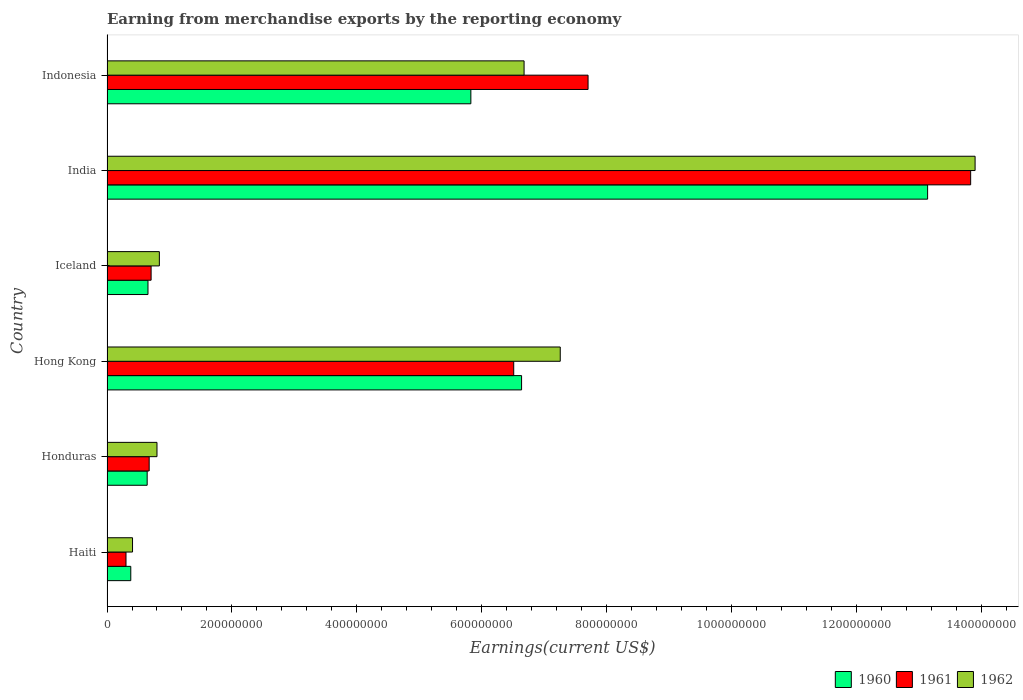How many different coloured bars are there?
Your response must be concise. 3. How many groups of bars are there?
Ensure brevity in your answer.  6. Are the number of bars per tick equal to the number of legend labels?
Offer a terse response. Yes. Are the number of bars on each tick of the Y-axis equal?
Give a very brief answer. Yes. How many bars are there on the 1st tick from the top?
Ensure brevity in your answer.  3. What is the label of the 1st group of bars from the top?
Give a very brief answer. Indonesia. In how many cases, is the number of bars for a given country not equal to the number of legend labels?
Your answer should be very brief. 0. What is the amount earned from merchandise exports in 1960 in Iceland?
Make the answer very short. 6.56e+07. Across all countries, what is the maximum amount earned from merchandise exports in 1961?
Provide a succinct answer. 1.38e+09. Across all countries, what is the minimum amount earned from merchandise exports in 1961?
Offer a terse response. 3.04e+07. In which country was the amount earned from merchandise exports in 1960 maximum?
Provide a succinct answer. India. In which country was the amount earned from merchandise exports in 1961 minimum?
Keep it short and to the point. Haiti. What is the total amount earned from merchandise exports in 1960 in the graph?
Provide a succinct answer. 2.73e+09. What is the difference between the amount earned from merchandise exports in 1960 in Honduras and that in Indonesia?
Offer a terse response. -5.18e+08. What is the difference between the amount earned from merchandise exports in 1962 in India and the amount earned from merchandise exports in 1961 in Haiti?
Your answer should be compact. 1.36e+09. What is the average amount earned from merchandise exports in 1962 per country?
Make the answer very short. 4.98e+08. What is the difference between the amount earned from merchandise exports in 1960 and amount earned from merchandise exports in 1961 in India?
Provide a short and direct response. -6.89e+07. What is the ratio of the amount earned from merchandise exports in 1961 in Haiti to that in Honduras?
Your answer should be very brief. 0.45. What is the difference between the highest and the second highest amount earned from merchandise exports in 1960?
Give a very brief answer. 6.50e+08. What is the difference between the highest and the lowest amount earned from merchandise exports in 1961?
Provide a succinct answer. 1.35e+09. In how many countries, is the amount earned from merchandise exports in 1961 greater than the average amount earned from merchandise exports in 1961 taken over all countries?
Keep it short and to the point. 3. What does the 3rd bar from the top in Honduras represents?
Provide a succinct answer. 1960. What does the 2nd bar from the bottom in Honduras represents?
Your answer should be very brief. 1961. Is it the case that in every country, the sum of the amount earned from merchandise exports in 1961 and amount earned from merchandise exports in 1962 is greater than the amount earned from merchandise exports in 1960?
Keep it short and to the point. Yes. How many countries are there in the graph?
Your response must be concise. 6. Does the graph contain any zero values?
Provide a succinct answer. No. Does the graph contain grids?
Make the answer very short. No. Where does the legend appear in the graph?
Provide a succinct answer. Bottom right. How many legend labels are there?
Ensure brevity in your answer.  3. How are the legend labels stacked?
Ensure brevity in your answer.  Horizontal. What is the title of the graph?
Keep it short and to the point. Earning from merchandise exports by the reporting economy. What is the label or title of the X-axis?
Your answer should be compact. Earnings(current US$). What is the Earnings(current US$) of 1960 in Haiti?
Offer a very short reply. 3.81e+07. What is the Earnings(current US$) of 1961 in Haiti?
Your answer should be compact. 3.04e+07. What is the Earnings(current US$) in 1962 in Haiti?
Make the answer very short. 4.09e+07. What is the Earnings(current US$) of 1960 in Honduras?
Give a very brief answer. 6.43e+07. What is the Earnings(current US$) of 1961 in Honduras?
Your answer should be compact. 6.75e+07. What is the Earnings(current US$) in 1962 in Honduras?
Keep it short and to the point. 8.00e+07. What is the Earnings(current US$) in 1960 in Hong Kong?
Your answer should be very brief. 6.64e+08. What is the Earnings(current US$) in 1961 in Hong Kong?
Provide a short and direct response. 6.51e+08. What is the Earnings(current US$) of 1962 in Hong Kong?
Ensure brevity in your answer.  7.26e+08. What is the Earnings(current US$) in 1960 in Iceland?
Provide a succinct answer. 6.56e+07. What is the Earnings(current US$) in 1961 in Iceland?
Give a very brief answer. 7.06e+07. What is the Earnings(current US$) in 1962 in Iceland?
Provide a succinct answer. 8.38e+07. What is the Earnings(current US$) in 1960 in India?
Your answer should be compact. 1.31e+09. What is the Earnings(current US$) in 1961 in India?
Give a very brief answer. 1.38e+09. What is the Earnings(current US$) of 1962 in India?
Your answer should be compact. 1.39e+09. What is the Earnings(current US$) of 1960 in Indonesia?
Keep it short and to the point. 5.82e+08. What is the Earnings(current US$) of 1961 in Indonesia?
Offer a very short reply. 7.70e+08. What is the Earnings(current US$) in 1962 in Indonesia?
Provide a succinct answer. 6.68e+08. Across all countries, what is the maximum Earnings(current US$) of 1960?
Your response must be concise. 1.31e+09. Across all countries, what is the maximum Earnings(current US$) in 1961?
Give a very brief answer. 1.38e+09. Across all countries, what is the maximum Earnings(current US$) of 1962?
Your response must be concise. 1.39e+09. Across all countries, what is the minimum Earnings(current US$) of 1960?
Provide a short and direct response. 3.81e+07. Across all countries, what is the minimum Earnings(current US$) of 1961?
Offer a very short reply. 3.04e+07. Across all countries, what is the minimum Earnings(current US$) of 1962?
Your answer should be very brief. 4.09e+07. What is the total Earnings(current US$) in 1960 in the graph?
Your answer should be very brief. 2.73e+09. What is the total Earnings(current US$) of 1961 in the graph?
Provide a succinct answer. 2.97e+09. What is the total Earnings(current US$) of 1962 in the graph?
Ensure brevity in your answer.  2.99e+09. What is the difference between the Earnings(current US$) in 1960 in Haiti and that in Honduras?
Your response must be concise. -2.62e+07. What is the difference between the Earnings(current US$) in 1961 in Haiti and that in Honduras?
Your answer should be very brief. -3.71e+07. What is the difference between the Earnings(current US$) of 1962 in Haiti and that in Honduras?
Your response must be concise. -3.91e+07. What is the difference between the Earnings(current US$) of 1960 in Haiti and that in Hong Kong?
Your answer should be very brief. -6.26e+08. What is the difference between the Earnings(current US$) of 1961 in Haiti and that in Hong Kong?
Provide a short and direct response. -6.21e+08. What is the difference between the Earnings(current US$) of 1962 in Haiti and that in Hong Kong?
Offer a terse response. -6.85e+08. What is the difference between the Earnings(current US$) of 1960 in Haiti and that in Iceland?
Make the answer very short. -2.75e+07. What is the difference between the Earnings(current US$) in 1961 in Haiti and that in Iceland?
Your answer should be very brief. -4.02e+07. What is the difference between the Earnings(current US$) in 1962 in Haiti and that in Iceland?
Provide a short and direct response. -4.29e+07. What is the difference between the Earnings(current US$) of 1960 in Haiti and that in India?
Keep it short and to the point. -1.28e+09. What is the difference between the Earnings(current US$) of 1961 in Haiti and that in India?
Your response must be concise. -1.35e+09. What is the difference between the Earnings(current US$) in 1962 in Haiti and that in India?
Give a very brief answer. -1.35e+09. What is the difference between the Earnings(current US$) of 1960 in Haiti and that in Indonesia?
Make the answer very short. -5.44e+08. What is the difference between the Earnings(current US$) in 1961 in Haiti and that in Indonesia?
Provide a succinct answer. -7.40e+08. What is the difference between the Earnings(current US$) of 1962 in Haiti and that in Indonesia?
Ensure brevity in your answer.  -6.27e+08. What is the difference between the Earnings(current US$) in 1960 in Honduras and that in Hong Kong?
Provide a succinct answer. -5.99e+08. What is the difference between the Earnings(current US$) of 1961 in Honduras and that in Hong Kong?
Your answer should be very brief. -5.84e+08. What is the difference between the Earnings(current US$) in 1962 in Honduras and that in Hong Kong?
Offer a terse response. -6.46e+08. What is the difference between the Earnings(current US$) in 1960 in Honduras and that in Iceland?
Provide a succinct answer. -1.30e+06. What is the difference between the Earnings(current US$) of 1961 in Honduras and that in Iceland?
Ensure brevity in your answer.  -3.10e+06. What is the difference between the Earnings(current US$) in 1962 in Honduras and that in Iceland?
Your response must be concise. -3.80e+06. What is the difference between the Earnings(current US$) of 1960 in Honduras and that in India?
Offer a very short reply. -1.25e+09. What is the difference between the Earnings(current US$) of 1961 in Honduras and that in India?
Make the answer very short. -1.31e+09. What is the difference between the Earnings(current US$) in 1962 in Honduras and that in India?
Offer a terse response. -1.31e+09. What is the difference between the Earnings(current US$) of 1960 in Honduras and that in Indonesia?
Provide a succinct answer. -5.18e+08. What is the difference between the Earnings(current US$) of 1961 in Honduras and that in Indonesia?
Make the answer very short. -7.02e+08. What is the difference between the Earnings(current US$) in 1962 in Honduras and that in Indonesia?
Give a very brief answer. -5.88e+08. What is the difference between the Earnings(current US$) of 1960 in Hong Kong and that in Iceland?
Provide a short and direct response. 5.98e+08. What is the difference between the Earnings(current US$) of 1961 in Hong Kong and that in Iceland?
Provide a succinct answer. 5.80e+08. What is the difference between the Earnings(current US$) of 1962 in Hong Kong and that in Iceland?
Make the answer very short. 6.42e+08. What is the difference between the Earnings(current US$) in 1960 in Hong Kong and that in India?
Your answer should be compact. -6.50e+08. What is the difference between the Earnings(current US$) in 1961 in Hong Kong and that in India?
Your answer should be compact. -7.31e+08. What is the difference between the Earnings(current US$) in 1962 in Hong Kong and that in India?
Give a very brief answer. -6.64e+08. What is the difference between the Earnings(current US$) in 1960 in Hong Kong and that in Indonesia?
Your answer should be very brief. 8.12e+07. What is the difference between the Earnings(current US$) of 1961 in Hong Kong and that in Indonesia?
Give a very brief answer. -1.19e+08. What is the difference between the Earnings(current US$) in 1962 in Hong Kong and that in Indonesia?
Give a very brief answer. 5.79e+07. What is the difference between the Earnings(current US$) of 1960 in Iceland and that in India?
Your answer should be compact. -1.25e+09. What is the difference between the Earnings(current US$) of 1961 in Iceland and that in India?
Provide a succinct answer. -1.31e+09. What is the difference between the Earnings(current US$) in 1962 in Iceland and that in India?
Provide a short and direct response. -1.31e+09. What is the difference between the Earnings(current US$) of 1960 in Iceland and that in Indonesia?
Your answer should be compact. -5.17e+08. What is the difference between the Earnings(current US$) of 1961 in Iceland and that in Indonesia?
Provide a short and direct response. -6.99e+08. What is the difference between the Earnings(current US$) in 1962 in Iceland and that in Indonesia?
Provide a succinct answer. -5.84e+08. What is the difference between the Earnings(current US$) in 1960 in India and that in Indonesia?
Ensure brevity in your answer.  7.31e+08. What is the difference between the Earnings(current US$) in 1961 in India and that in Indonesia?
Your answer should be very brief. 6.12e+08. What is the difference between the Earnings(current US$) of 1962 in India and that in Indonesia?
Your answer should be very brief. 7.22e+08. What is the difference between the Earnings(current US$) in 1960 in Haiti and the Earnings(current US$) in 1961 in Honduras?
Offer a terse response. -2.94e+07. What is the difference between the Earnings(current US$) in 1960 in Haiti and the Earnings(current US$) in 1962 in Honduras?
Make the answer very short. -4.19e+07. What is the difference between the Earnings(current US$) of 1961 in Haiti and the Earnings(current US$) of 1962 in Honduras?
Provide a short and direct response. -4.96e+07. What is the difference between the Earnings(current US$) in 1960 in Haiti and the Earnings(current US$) in 1961 in Hong Kong?
Your answer should be very brief. -6.13e+08. What is the difference between the Earnings(current US$) of 1960 in Haiti and the Earnings(current US$) of 1962 in Hong Kong?
Keep it short and to the point. -6.87e+08. What is the difference between the Earnings(current US$) in 1961 in Haiti and the Earnings(current US$) in 1962 in Hong Kong?
Your answer should be compact. -6.95e+08. What is the difference between the Earnings(current US$) in 1960 in Haiti and the Earnings(current US$) in 1961 in Iceland?
Make the answer very short. -3.25e+07. What is the difference between the Earnings(current US$) of 1960 in Haiti and the Earnings(current US$) of 1962 in Iceland?
Your answer should be very brief. -4.57e+07. What is the difference between the Earnings(current US$) of 1961 in Haiti and the Earnings(current US$) of 1962 in Iceland?
Keep it short and to the point. -5.34e+07. What is the difference between the Earnings(current US$) in 1960 in Haiti and the Earnings(current US$) in 1961 in India?
Make the answer very short. -1.34e+09. What is the difference between the Earnings(current US$) in 1960 in Haiti and the Earnings(current US$) in 1962 in India?
Provide a succinct answer. -1.35e+09. What is the difference between the Earnings(current US$) of 1961 in Haiti and the Earnings(current US$) of 1962 in India?
Offer a very short reply. -1.36e+09. What is the difference between the Earnings(current US$) of 1960 in Haiti and the Earnings(current US$) of 1961 in Indonesia?
Keep it short and to the point. -7.32e+08. What is the difference between the Earnings(current US$) of 1960 in Haiti and the Earnings(current US$) of 1962 in Indonesia?
Your answer should be compact. -6.30e+08. What is the difference between the Earnings(current US$) of 1961 in Haiti and the Earnings(current US$) of 1962 in Indonesia?
Provide a succinct answer. -6.37e+08. What is the difference between the Earnings(current US$) in 1960 in Honduras and the Earnings(current US$) in 1961 in Hong Kong?
Your response must be concise. -5.87e+08. What is the difference between the Earnings(current US$) of 1960 in Honduras and the Earnings(current US$) of 1962 in Hong Kong?
Provide a short and direct response. -6.61e+08. What is the difference between the Earnings(current US$) of 1961 in Honduras and the Earnings(current US$) of 1962 in Hong Kong?
Offer a very short reply. -6.58e+08. What is the difference between the Earnings(current US$) of 1960 in Honduras and the Earnings(current US$) of 1961 in Iceland?
Offer a very short reply. -6.30e+06. What is the difference between the Earnings(current US$) in 1960 in Honduras and the Earnings(current US$) in 1962 in Iceland?
Provide a short and direct response. -1.95e+07. What is the difference between the Earnings(current US$) of 1961 in Honduras and the Earnings(current US$) of 1962 in Iceland?
Ensure brevity in your answer.  -1.63e+07. What is the difference between the Earnings(current US$) of 1960 in Honduras and the Earnings(current US$) of 1961 in India?
Your answer should be compact. -1.32e+09. What is the difference between the Earnings(current US$) in 1960 in Honduras and the Earnings(current US$) in 1962 in India?
Your answer should be very brief. -1.33e+09. What is the difference between the Earnings(current US$) in 1961 in Honduras and the Earnings(current US$) in 1962 in India?
Your answer should be compact. -1.32e+09. What is the difference between the Earnings(current US$) of 1960 in Honduras and the Earnings(current US$) of 1961 in Indonesia?
Provide a short and direct response. -7.06e+08. What is the difference between the Earnings(current US$) in 1960 in Honduras and the Earnings(current US$) in 1962 in Indonesia?
Ensure brevity in your answer.  -6.03e+08. What is the difference between the Earnings(current US$) in 1961 in Honduras and the Earnings(current US$) in 1962 in Indonesia?
Give a very brief answer. -6.00e+08. What is the difference between the Earnings(current US$) of 1960 in Hong Kong and the Earnings(current US$) of 1961 in Iceland?
Ensure brevity in your answer.  5.93e+08. What is the difference between the Earnings(current US$) in 1960 in Hong Kong and the Earnings(current US$) in 1962 in Iceland?
Your answer should be compact. 5.80e+08. What is the difference between the Earnings(current US$) of 1961 in Hong Kong and the Earnings(current US$) of 1962 in Iceland?
Keep it short and to the point. 5.67e+08. What is the difference between the Earnings(current US$) in 1960 in Hong Kong and the Earnings(current US$) in 1961 in India?
Offer a very short reply. -7.19e+08. What is the difference between the Earnings(current US$) of 1960 in Hong Kong and the Earnings(current US$) of 1962 in India?
Give a very brief answer. -7.26e+08. What is the difference between the Earnings(current US$) of 1961 in Hong Kong and the Earnings(current US$) of 1962 in India?
Offer a terse response. -7.38e+08. What is the difference between the Earnings(current US$) of 1960 in Hong Kong and the Earnings(current US$) of 1961 in Indonesia?
Give a very brief answer. -1.06e+08. What is the difference between the Earnings(current US$) in 1961 in Hong Kong and the Earnings(current US$) in 1962 in Indonesia?
Ensure brevity in your answer.  -1.66e+07. What is the difference between the Earnings(current US$) of 1960 in Iceland and the Earnings(current US$) of 1961 in India?
Your response must be concise. -1.32e+09. What is the difference between the Earnings(current US$) of 1960 in Iceland and the Earnings(current US$) of 1962 in India?
Provide a succinct answer. -1.32e+09. What is the difference between the Earnings(current US$) in 1961 in Iceland and the Earnings(current US$) in 1962 in India?
Ensure brevity in your answer.  -1.32e+09. What is the difference between the Earnings(current US$) in 1960 in Iceland and the Earnings(current US$) in 1961 in Indonesia?
Provide a succinct answer. -7.04e+08. What is the difference between the Earnings(current US$) of 1960 in Iceland and the Earnings(current US$) of 1962 in Indonesia?
Your answer should be very brief. -6.02e+08. What is the difference between the Earnings(current US$) in 1961 in Iceland and the Earnings(current US$) in 1962 in Indonesia?
Your answer should be very brief. -5.97e+08. What is the difference between the Earnings(current US$) in 1960 in India and the Earnings(current US$) in 1961 in Indonesia?
Your answer should be compact. 5.44e+08. What is the difference between the Earnings(current US$) in 1960 in India and the Earnings(current US$) in 1962 in Indonesia?
Your answer should be compact. 6.46e+08. What is the difference between the Earnings(current US$) of 1961 in India and the Earnings(current US$) of 1962 in Indonesia?
Make the answer very short. 7.15e+08. What is the average Earnings(current US$) in 1960 per country?
Keep it short and to the point. 4.55e+08. What is the average Earnings(current US$) of 1961 per country?
Your answer should be compact. 4.95e+08. What is the average Earnings(current US$) in 1962 per country?
Give a very brief answer. 4.98e+08. What is the difference between the Earnings(current US$) of 1960 and Earnings(current US$) of 1961 in Haiti?
Offer a very short reply. 7.64e+06. What is the difference between the Earnings(current US$) of 1960 and Earnings(current US$) of 1962 in Haiti?
Your answer should be compact. -2.82e+06. What is the difference between the Earnings(current US$) of 1961 and Earnings(current US$) of 1962 in Haiti?
Offer a very short reply. -1.05e+07. What is the difference between the Earnings(current US$) in 1960 and Earnings(current US$) in 1961 in Honduras?
Keep it short and to the point. -3.20e+06. What is the difference between the Earnings(current US$) of 1960 and Earnings(current US$) of 1962 in Honduras?
Your answer should be very brief. -1.57e+07. What is the difference between the Earnings(current US$) in 1961 and Earnings(current US$) in 1962 in Honduras?
Your answer should be compact. -1.25e+07. What is the difference between the Earnings(current US$) of 1960 and Earnings(current US$) of 1961 in Hong Kong?
Give a very brief answer. 1.26e+07. What is the difference between the Earnings(current US$) in 1960 and Earnings(current US$) in 1962 in Hong Kong?
Your response must be concise. -6.19e+07. What is the difference between the Earnings(current US$) of 1961 and Earnings(current US$) of 1962 in Hong Kong?
Keep it short and to the point. -7.45e+07. What is the difference between the Earnings(current US$) in 1960 and Earnings(current US$) in 1961 in Iceland?
Keep it short and to the point. -5.00e+06. What is the difference between the Earnings(current US$) of 1960 and Earnings(current US$) of 1962 in Iceland?
Your answer should be very brief. -1.82e+07. What is the difference between the Earnings(current US$) in 1961 and Earnings(current US$) in 1962 in Iceland?
Give a very brief answer. -1.32e+07. What is the difference between the Earnings(current US$) of 1960 and Earnings(current US$) of 1961 in India?
Provide a succinct answer. -6.89e+07. What is the difference between the Earnings(current US$) of 1960 and Earnings(current US$) of 1962 in India?
Keep it short and to the point. -7.60e+07. What is the difference between the Earnings(current US$) of 1961 and Earnings(current US$) of 1962 in India?
Provide a succinct answer. -7.10e+06. What is the difference between the Earnings(current US$) in 1960 and Earnings(current US$) in 1961 in Indonesia?
Offer a very short reply. -1.88e+08. What is the difference between the Earnings(current US$) of 1960 and Earnings(current US$) of 1962 in Indonesia?
Offer a very short reply. -8.52e+07. What is the difference between the Earnings(current US$) of 1961 and Earnings(current US$) of 1962 in Indonesia?
Your answer should be very brief. 1.02e+08. What is the ratio of the Earnings(current US$) of 1960 in Haiti to that in Honduras?
Keep it short and to the point. 0.59. What is the ratio of the Earnings(current US$) of 1961 in Haiti to that in Honduras?
Keep it short and to the point. 0.45. What is the ratio of the Earnings(current US$) in 1962 in Haiti to that in Honduras?
Your answer should be very brief. 0.51. What is the ratio of the Earnings(current US$) of 1960 in Haiti to that in Hong Kong?
Offer a very short reply. 0.06. What is the ratio of the Earnings(current US$) of 1961 in Haiti to that in Hong Kong?
Keep it short and to the point. 0.05. What is the ratio of the Earnings(current US$) of 1962 in Haiti to that in Hong Kong?
Offer a terse response. 0.06. What is the ratio of the Earnings(current US$) of 1960 in Haiti to that in Iceland?
Offer a terse response. 0.58. What is the ratio of the Earnings(current US$) of 1961 in Haiti to that in Iceland?
Your answer should be compact. 0.43. What is the ratio of the Earnings(current US$) of 1962 in Haiti to that in Iceland?
Your response must be concise. 0.49. What is the ratio of the Earnings(current US$) of 1960 in Haiti to that in India?
Your response must be concise. 0.03. What is the ratio of the Earnings(current US$) in 1961 in Haiti to that in India?
Offer a very short reply. 0.02. What is the ratio of the Earnings(current US$) of 1962 in Haiti to that in India?
Your answer should be very brief. 0.03. What is the ratio of the Earnings(current US$) in 1960 in Haiti to that in Indonesia?
Your answer should be compact. 0.07. What is the ratio of the Earnings(current US$) in 1961 in Haiti to that in Indonesia?
Offer a terse response. 0.04. What is the ratio of the Earnings(current US$) of 1962 in Haiti to that in Indonesia?
Provide a succinct answer. 0.06. What is the ratio of the Earnings(current US$) in 1960 in Honduras to that in Hong Kong?
Give a very brief answer. 0.1. What is the ratio of the Earnings(current US$) of 1961 in Honduras to that in Hong Kong?
Offer a terse response. 0.1. What is the ratio of the Earnings(current US$) of 1962 in Honduras to that in Hong Kong?
Provide a succinct answer. 0.11. What is the ratio of the Earnings(current US$) in 1960 in Honduras to that in Iceland?
Your answer should be compact. 0.98. What is the ratio of the Earnings(current US$) of 1961 in Honduras to that in Iceland?
Offer a very short reply. 0.96. What is the ratio of the Earnings(current US$) of 1962 in Honduras to that in Iceland?
Make the answer very short. 0.95. What is the ratio of the Earnings(current US$) in 1960 in Honduras to that in India?
Make the answer very short. 0.05. What is the ratio of the Earnings(current US$) of 1961 in Honduras to that in India?
Offer a very short reply. 0.05. What is the ratio of the Earnings(current US$) of 1962 in Honduras to that in India?
Your answer should be compact. 0.06. What is the ratio of the Earnings(current US$) of 1960 in Honduras to that in Indonesia?
Your response must be concise. 0.11. What is the ratio of the Earnings(current US$) in 1961 in Honduras to that in Indonesia?
Ensure brevity in your answer.  0.09. What is the ratio of the Earnings(current US$) of 1962 in Honduras to that in Indonesia?
Your response must be concise. 0.12. What is the ratio of the Earnings(current US$) of 1960 in Hong Kong to that in Iceland?
Ensure brevity in your answer.  10.12. What is the ratio of the Earnings(current US$) of 1961 in Hong Kong to that in Iceland?
Provide a succinct answer. 9.22. What is the ratio of the Earnings(current US$) of 1962 in Hong Kong to that in Iceland?
Offer a terse response. 8.66. What is the ratio of the Earnings(current US$) in 1960 in Hong Kong to that in India?
Your answer should be very brief. 0.51. What is the ratio of the Earnings(current US$) in 1961 in Hong Kong to that in India?
Give a very brief answer. 0.47. What is the ratio of the Earnings(current US$) in 1962 in Hong Kong to that in India?
Keep it short and to the point. 0.52. What is the ratio of the Earnings(current US$) in 1960 in Hong Kong to that in Indonesia?
Your response must be concise. 1.14. What is the ratio of the Earnings(current US$) in 1961 in Hong Kong to that in Indonesia?
Your response must be concise. 0.85. What is the ratio of the Earnings(current US$) of 1962 in Hong Kong to that in Indonesia?
Offer a terse response. 1.09. What is the ratio of the Earnings(current US$) of 1960 in Iceland to that in India?
Your answer should be compact. 0.05. What is the ratio of the Earnings(current US$) of 1961 in Iceland to that in India?
Keep it short and to the point. 0.05. What is the ratio of the Earnings(current US$) in 1962 in Iceland to that in India?
Offer a very short reply. 0.06. What is the ratio of the Earnings(current US$) in 1960 in Iceland to that in Indonesia?
Your answer should be compact. 0.11. What is the ratio of the Earnings(current US$) in 1961 in Iceland to that in Indonesia?
Provide a short and direct response. 0.09. What is the ratio of the Earnings(current US$) in 1962 in Iceland to that in Indonesia?
Offer a very short reply. 0.13. What is the ratio of the Earnings(current US$) in 1960 in India to that in Indonesia?
Offer a terse response. 2.26. What is the ratio of the Earnings(current US$) in 1961 in India to that in Indonesia?
Ensure brevity in your answer.  1.8. What is the ratio of the Earnings(current US$) of 1962 in India to that in Indonesia?
Offer a very short reply. 2.08. What is the difference between the highest and the second highest Earnings(current US$) in 1960?
Ensure brevity in your answer.  6.50e+08. What is the difference between the highest and the second highest Earnings(current US$) in 1961?
Give a very brief answer. 6.12e+08. What is the difference between the highest and the second highest Earnings(current US$) in 1962?
Keep it short and to the point. 6.64e+08. What is the difference between the highest and the lowest Earnings(current US$) of 1960?
Your answer should be compact. 1.28e+09. What is the difference between the highest and the lowest Earnings(current US$) in 1961?
Provide a succinct answer. 1.35e+09. What is the difference between the highest and the lowest Earnings(current US$) in 1962?
Your response must be concise. 1.35e+09. 